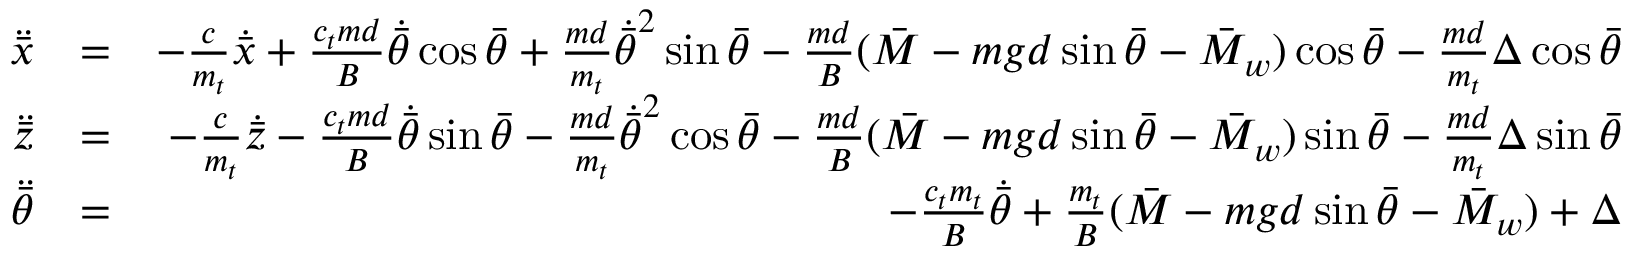Convert formula to latex. <formula><loc_0><loc_0><loc_500><loc_500>\begin{array} { r l r } { \ddot { \bar { x } } } & { = } & { - \frac { c } { m _ { t } } \dot { \bar { x } } + \frac { c _ { t } m d } { B } \dot { \bar { \theta } } \cos \bar { \theta } + \frac { m d } { m _ { t } } \dot { \bar { \theta } } ^ { 2 } \sin \bar { \theta } - \frac { m d } { B } ( \bar { M } - m g d \sin \bar { \theta } - \bar { M } _ { w } ) \cos \bar { \theta } - \frac { m d } { m _ { t } } \Delta \cos \bar { \theta } } \\ { \ddot { \bar { z } } } & { = } & { - \frac { c } { m _ { t } } \dot { \bar { z } } - \frac { c _ { t } m d } { B } \dot { \bar { \theta } } \sin \bar { \theta } - \frac { m d } { m _ { t } } \dot { \bar { \theta } } ^ { 2 } \cos \bar { \theta } - \frac { m d } { B } ( \bar { M } - m g d \sin \bar { \theta } - \bar { M } _ { w } ) \sin \bar { \theta } - \frac { m d } { m _ { t } } \Delta \sin \bar { \theta } } \\ { \ddot { \bar { \theta } } } & { = } & { - \frac { c _ { t } m _ { t } } { B } \dot { \bar { \theta } } + \frac { m _ { t } } { B } ( \bar { M } - m g d \sin \bar { \theta } - \bar { M } _ { w } ) + \Delta } \end{array}</formula> 